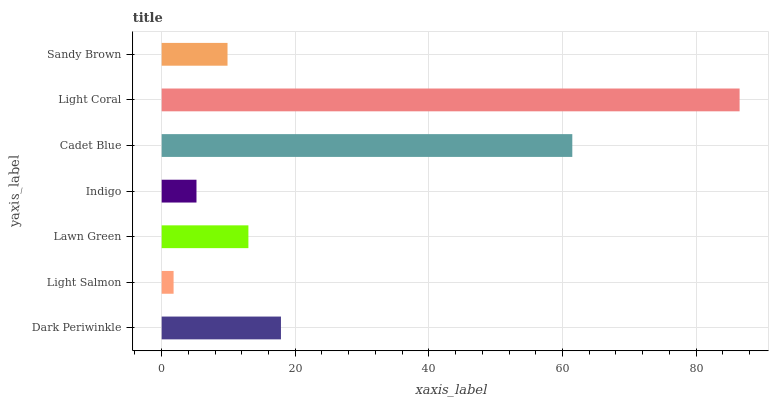Is Light Salmon the minimum?
Answer yes or no. Yes. Is Light Coral the maximum?
Answer yes or no. Yes. Is Lawn Green the minimum?
Answer yes or no. No. Is Lawn Green the maximum?
Answer yes or no. No. Is Lawn Green greater than Light Salmon?
Answer yes or no. Yes. Is Light Salmon less than Lawn Green?
Answer yes or no. Yes. Is Light Salmon greater than Lawn Green?
Answer yes or no. No. Is Lawn Green less than Light Salmon?
Answer yes or no. No. Is Lawn Green the high median?
Answer yes or no. Yes. Is Lawn Green the low median?
Answer yes or no. Yes. Is Light Salmon the high median?
Answer yes or no. No. Is Light Salmon the low median?
Answer yes or no. No. 